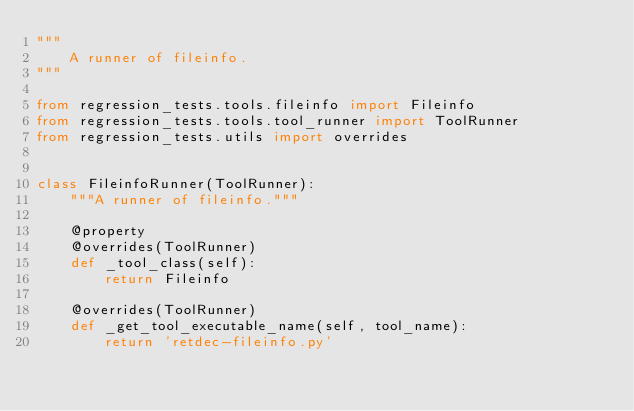Convert code to text. <code><loc_0><loc_0><loc_500><loc_500><_Python_>"""
    A runner of fileinfo.
"""

from regression_tests.tools.fileinfo import Fileinfo
from regression_tests.tools.tool_runner import ToolRunner
from regression_tests.utils import overrides


class FileinfoRunner(ToolRunner):
    """A runner of fileinfo."""

    @property
    @overrides(ToolRunner)
    def _tool_class(self):
        return Fileinfo

    @overrides(ToolRunner)
    def _get_tool_executable_name(self, tool_name):
        return 'retdec-fileinfo.py'
</code> 